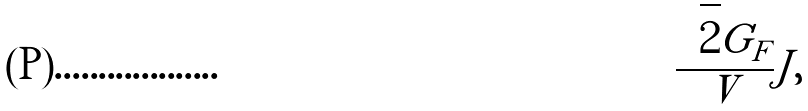Convert formula to latex. <formula><loc_0><loc_0><loc_500><loc_500>\frac { \sqrt { 2 } G _ { F } } V { J } ,</formula> 